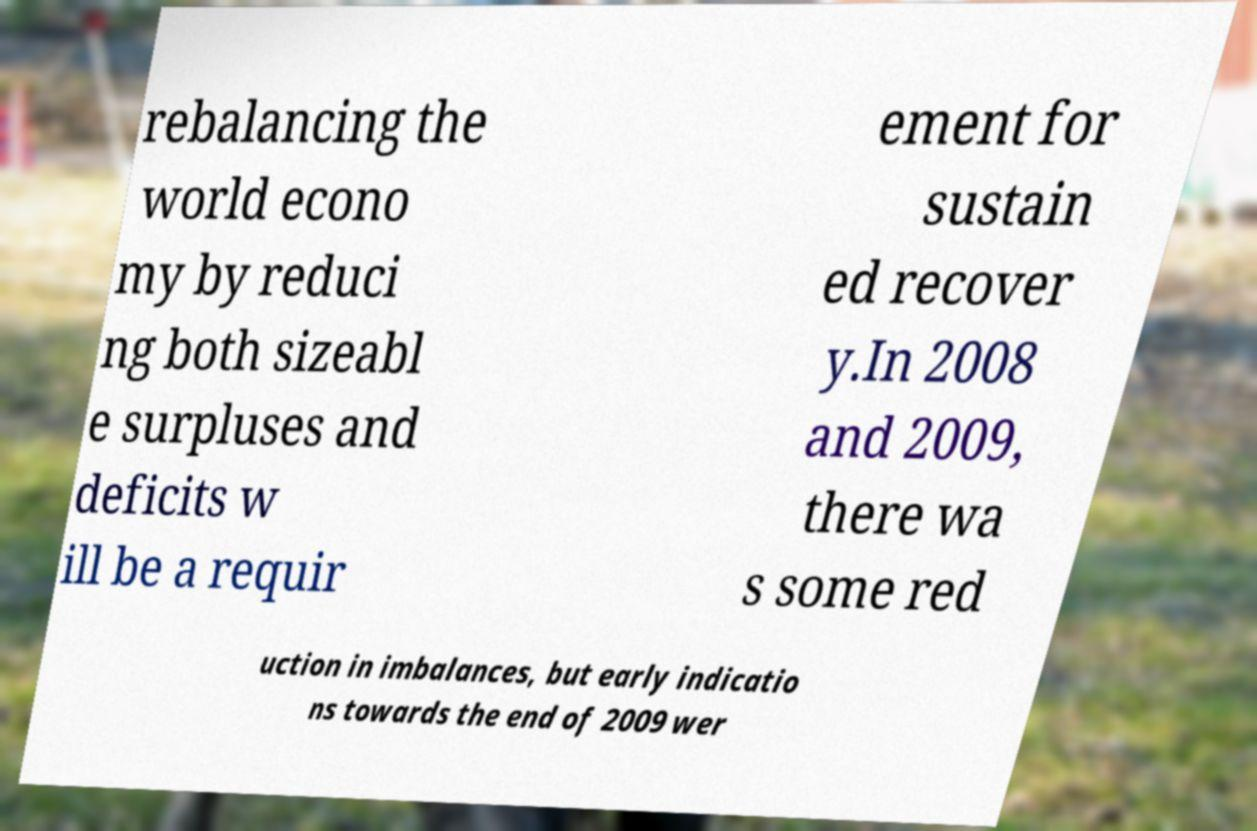For documentation purposes, I need the text within this image transcribed. Could you provide that? rebalancing the world econo my by reduci ng both sizeabl e surpluses and deficits w ill be a requir ement for sustain ed recover y.In 2008 and 2009, there wa s some red uction in imbalances, but early indicatio ns towards the end of 2009 wer 